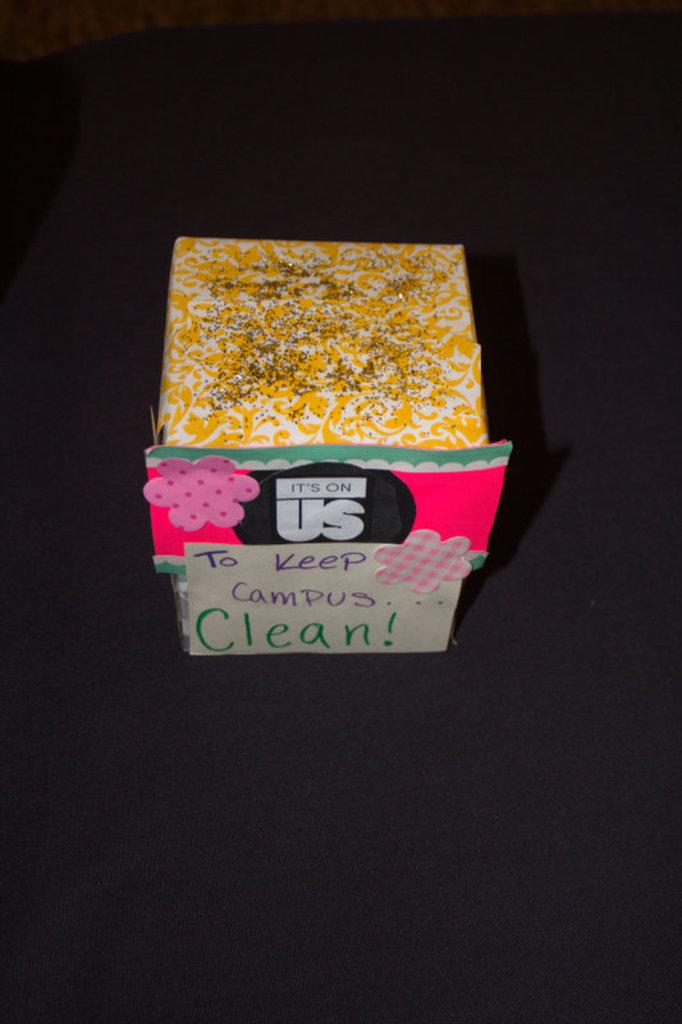Provide a one-sentence caption for the provided image. Small colorful box hand decorated stating that it is on us to keep the campus clean. 